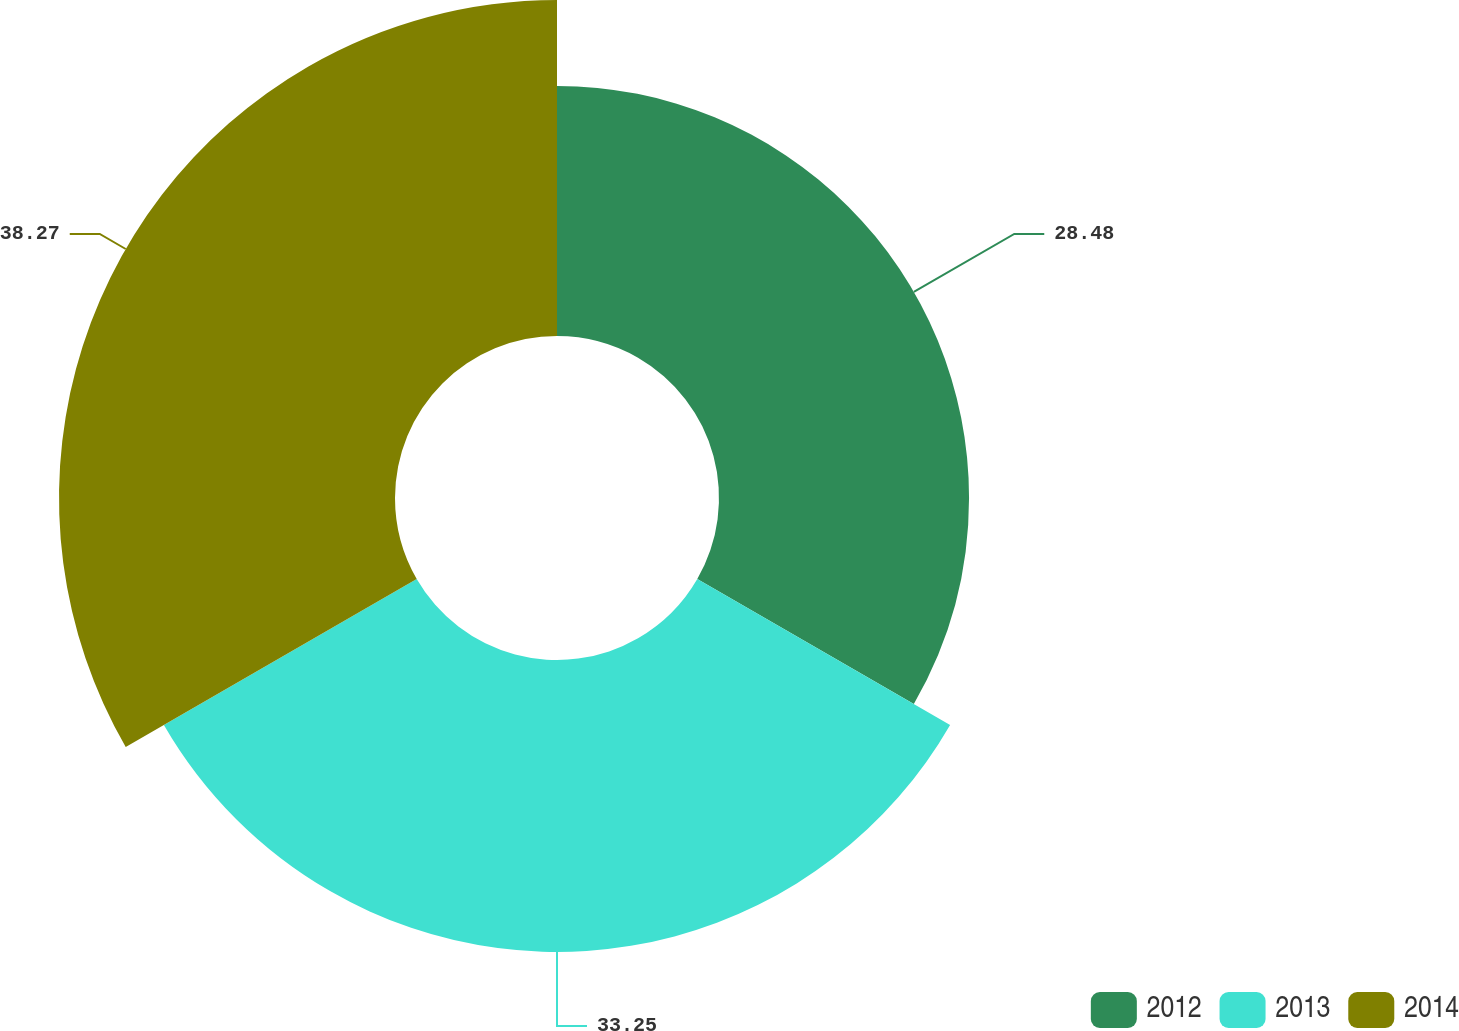Convert chart to OTSL. <chart><loc_0><loc_0><loc_500><loc_500><pie_chart><fcel>2012<fcel>2013<fcel>2014<nl><fcel>28.48%<fcel>33.25%<fcel>38.27%<nl></chart> 